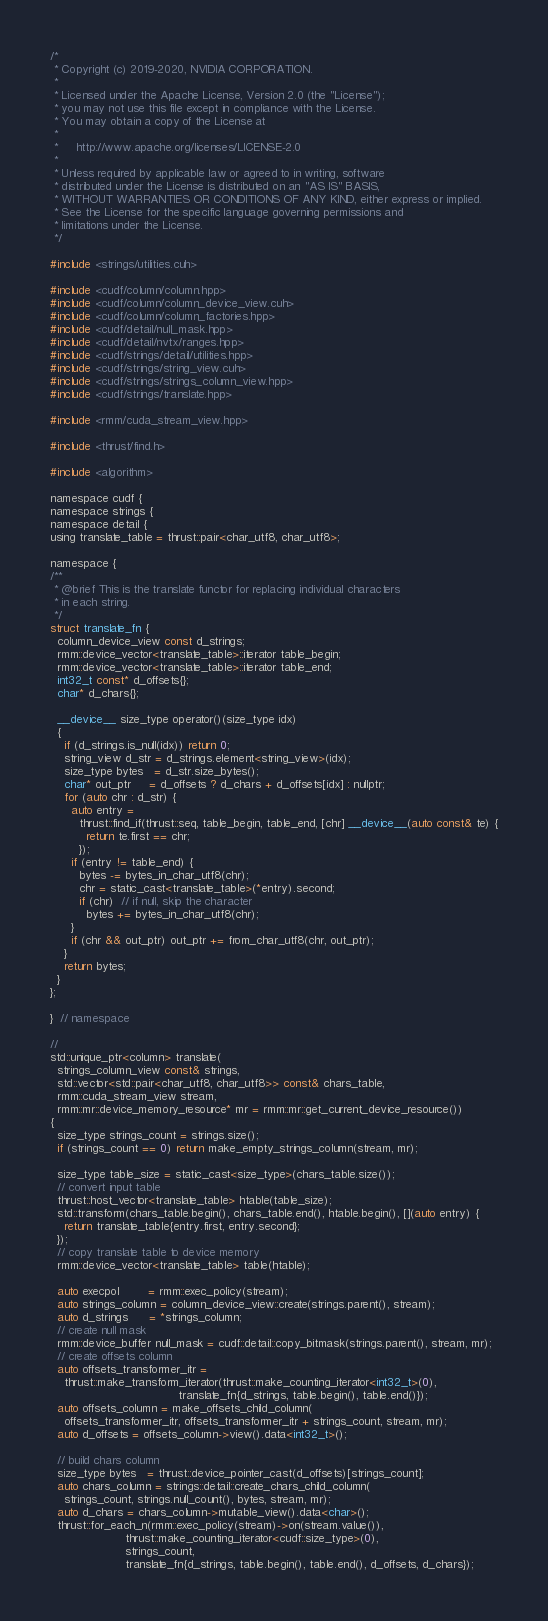<code> <loc_0><loc_0><loc_500><loc_500><_Cuda_>/*
 * Copyright (c) 2019-2020, NVIDIA CORPORATION.
 *
 * Licensed under the Apache License, Version 2.0 (the "License");
 * you may not use this file except in compliance with the License.
 * You may obtain a copy of the License at
 *
 *     http://www.apache.org/licenses/LICENSE-2.0
 *
 * Unless required by applicable law or agreed to in writing, software
 * distributed under the License is distributed on an "AS IS" BASIS,
 * WITHOUT WARRANTIES OR CONDITIONS OF ANY KIND, either express or implied.
 * See the License for the specific language governing permissions and
 * limitations under the License.
 */

#include <strings/utilities.cuh>

#include <cudf/column/column.hpp>
#include <cudf/column/column_device_view.cuh>
#include <cudf/column/column_factories.hpp>
#include <cudf/detail/null_mask.hpp>
#include <cudf/detail/nvtx/ranges.hpp>
#include <cudf/strings/detail/utilities.hpp>
#include <cudf/strings/string_view.cuh>
#include <cudf/strings/strings_column_view.hpp>
#include <cudf/strings/translate.hpp>

#include <rmm/cuda_stream_view.hpp>

#include <thrust/find.h>

#include <algorithm>

namespace cudf {
namespace strings {
namespace detail {
using translate_table = thrust::pair<char_utf8, char_utf8>;

namespace {
/**
 * @brief This is the translate functor for replacing individual characters
 * in each string.
 */
struct translate_fn {
  column_device_view const d_strings;
  rmm::device_vector<translate_table>::iterator table_begin;
  rmm::device_vector<translate_table>::iterator table_end;
  int32_t const* d_offsets{};
  char* d_chars{};

  __device__ size_type operator()(size_type idx)
  {
    if (d_strings.is_null(idx)) return 0;
    string_view d_str = d_strings.element<string_view>(idx);
    size_type bytes   = d_str.size_bytes();
    char* out_ptr     = d_offsets ? d_chars + d_offsets[idx] : nullptr;
    for (auto chr : d_str) {
      auto entry =
        thrust::find_if(thrust::seq, table_begin, table_end, [chr] __device__(auto const& te) {
          return te.first == chr;
        });
      if (entry != table_end) {
        bytes -= bytes_in_char_utf8(chr);
        chr = static_cast<translate_table>(*entry).second;
        if (chr)  // if null, skip the character
          bytes += bytes_in_char_utf8(chr);
      }
      if (chr && out_ptr) out_ptr += from_char_utf8(chr, out_ptr);
    }
    return bytes;
  }
};

}  // namespace

//
std::unique_ptr<column> translate(
  strings_column_view const& strings,
  std::vector<std::pair<char_utf8, char_utf8>> const& chars_table,
  rmm::cuda_stream_view stream,
  rmm::mr::device_memory_resource* mr = rmm::mr::get_current_device_resource())
{
  size_type strings_count = strings.size();
  if (strings_count == 0) return make_empty_strings_column(stream, mr);

  size_type table_size = static_cast<size_type>(chars_table.size());
  // convert input table
  thrust::host_vector<translate_table> htable(table_size);
  std::transform(chars_table.begin(), chars_table.end(), htable.begin(), [](auto entry) {
    return translate_table{entry.first, entry.second};
  });
  // copy translate table to device memory
  rmm::device_vector<translate_table> table(htable);

  auto execpol        = rmm::exec_policy(stream);
  auto strings_column = column_device_view::create(strings.parent(), stream);
  auto d_strings      = *strings_column;
  // create null mask
  rmm::device_buffer null_mask = cudf::detail::copy_bitmask(strings.parent(), stream, mr);
  // create offsets column
  auto offsets_transformer_itr =
    thrust::make_transform_iterator(thrust::make_counting_iterator<int32_t>(0),
                                    translate_fn{d_strings, table.begin(), table.end()});
  auto offsets_column = make_offsets_child_column(
    offsets_transformer_itr, offsets_transformer_itr + strings_count, stream, mr);
  auto d_offsets = offsets_column->view().data<int32_t>();

  // build chars column
  size_type bytes   = thrust::device_pointer_cast(d_offsets)[strings_count];
  auto chars_column = strings::detail::create_chars_child_column(
    strings_count, strings.null_count(), bytes, stream, mr);
  auto d_chars = chars_column->mutable_view().data<char>();
  thrust::for_each_n(rmm::exec_policy(stream)->on(stream.value()),
                     thrust::make_counting_iterator<cudf::size_type>(0),
                     strings_count,
                     translate_fn{d_strings, table.begin(), table.end(), d_offsets, d_chars});
</code> 